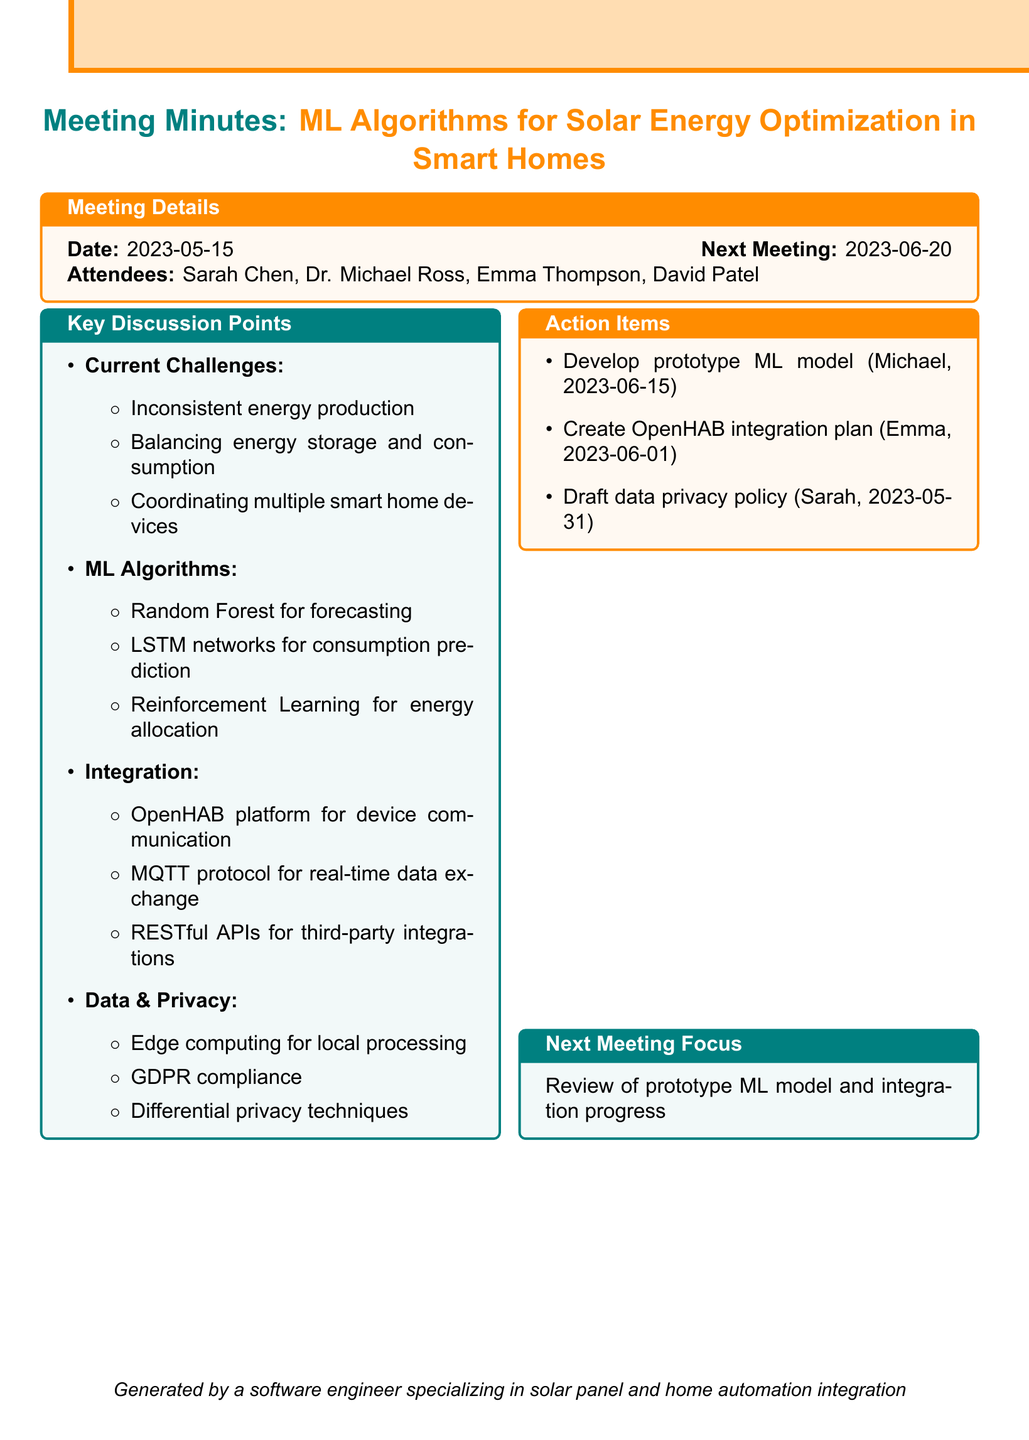What is the date of the meeting? The date of the meeting is explicitly stated in the document.
Answer: 2023-05-15 Who is the assignee for developing the prototype ML model? The document lists action items with specific assignees for each task.
Answer: Dr. Michael Ross What are the potential ML algorithms mentioned in the discussion? The document includes key discussion points that outline potential ML algorithms.
Answer: Random Forest, LSTM networks, Reinforcement Learning What is the deadline for creating the integration plan for the OpenHAB platform? The document specifies deadlines for each action item along with the assignees.
Answer: 2023-06-01 What is one of the challenges discussed regarding solar energy optimization? The document outlines several challenges under the key discussion points section.
Answer: Inconsistent energy production due to weather variations When is the next meeting scheduled? The document contains a section that indicates the next meeting date and focus.
Answer: 2023-06-20 What approach is suggested for ensuring data privacy? The document addresses data collection and privacy concerns, listing several approaches.
Answer: Differential privacy techniques Which platform is recommended for device communication? The document details integration points for home automation and mentions specific platforms.
Answer: OpenHAB 